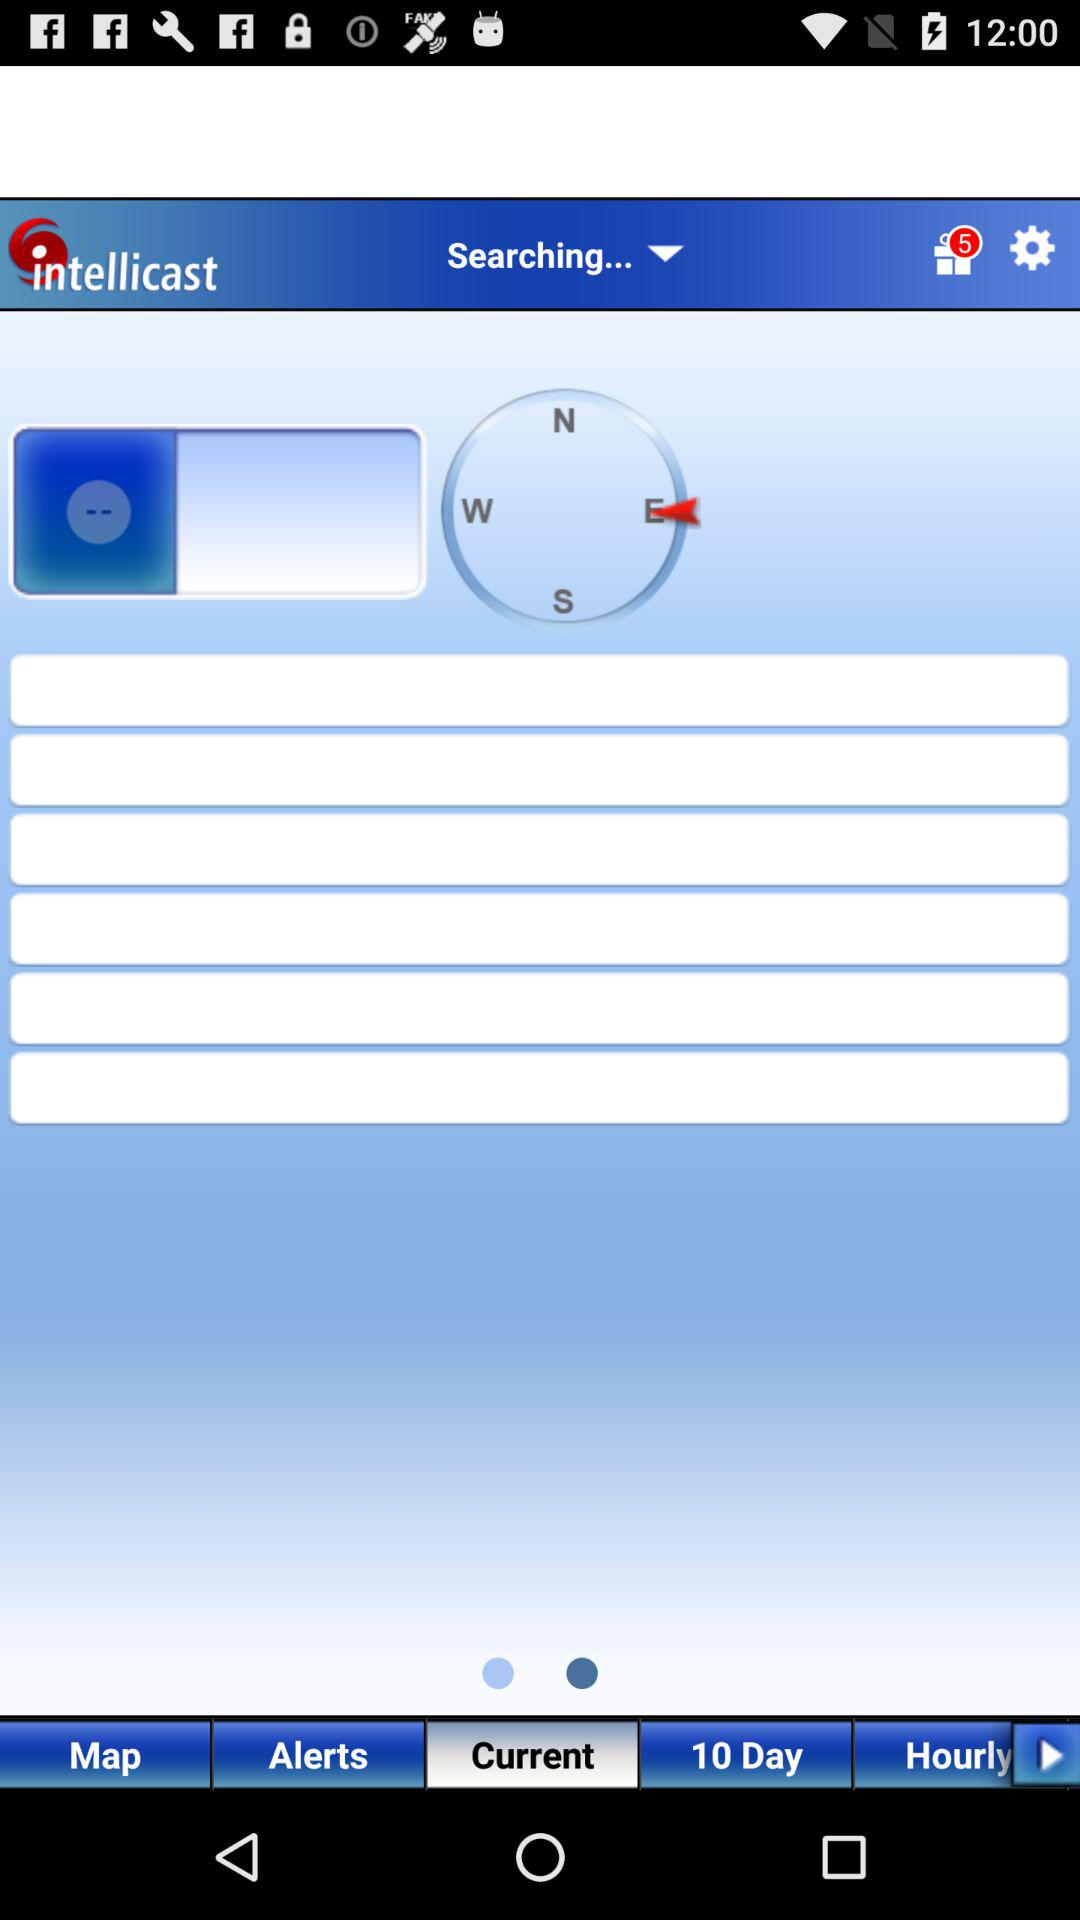Which direction has the arrow indicated? The direction is "E". 